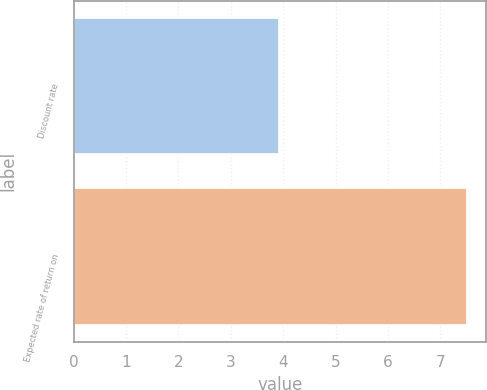Convert chart to OTSL. <chart><loc_0><loc_0><loc_500><loc_500><bar_chart><fcel>Discount rate<fcel>Expected rate of return on<nl><fcel>3.92<fcel>7.5<nl></chart> 